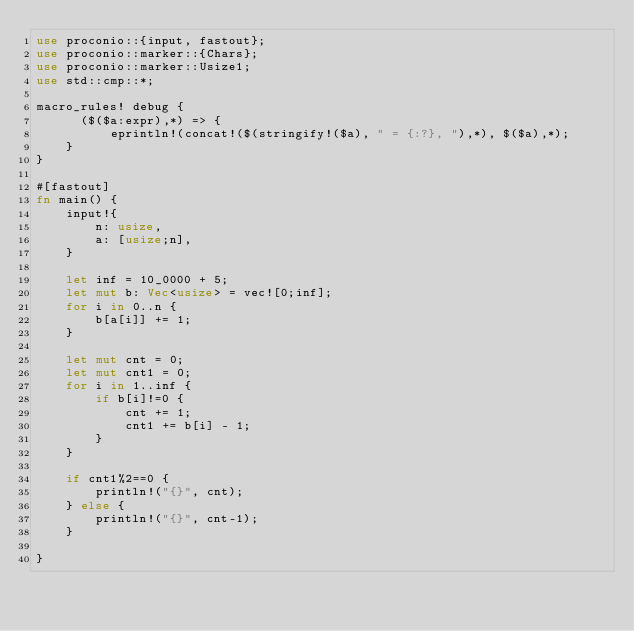<code> <loc_0><loc_0><loc_500><loc_500><_Rust_>use proconio::{input, fastout};
use proconio::marker::{Chars};
use proconio::marker::Usize1;
use std::cmp::*;

macro_rules! debug {
      ($($a:expr),*) => {
          eprintln!(concat!($(stringify!($a), " = {:?}, "),*), $($a),*);
    }
}

#[fastout]
fn main() {
    input!{
        n: usize,
        a: [usize;n],
    }

    let inf = 10_0000 + 5;
    let mut b: Vec<usize> = vec![0;inf];
    for i in 0..n {
        b[a[i]] += 1;
    }

    let mut cnt = 0;
    let mut cnt1 = 0;
    for i in 1..inf {
        if b[i]!=0 {
            cnt += 1;
            cnt1 += b[i] - 1;
        }
    }

    if cnt1%2==0 {
        println!("{}", cnt);
    } else {
        println!("{}", cnt-1);
    }

}
</code> 